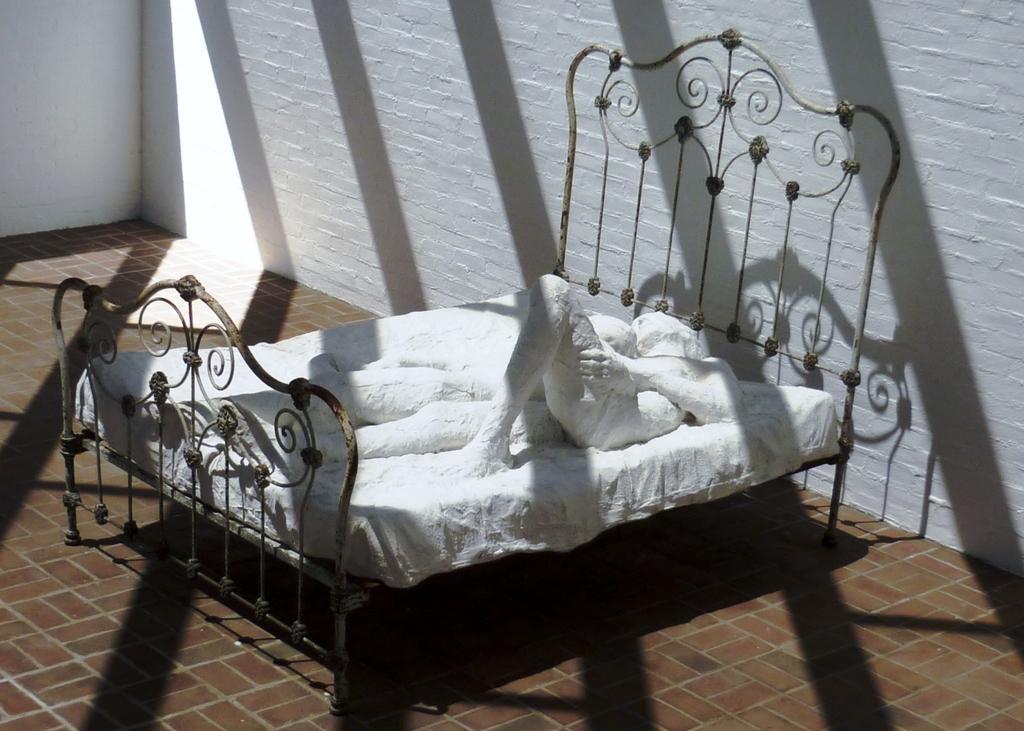Could you give a brief overview of what you see in this image? In this picture we can see a cot on the floor with a statue on it and in the background we can see the walls. 